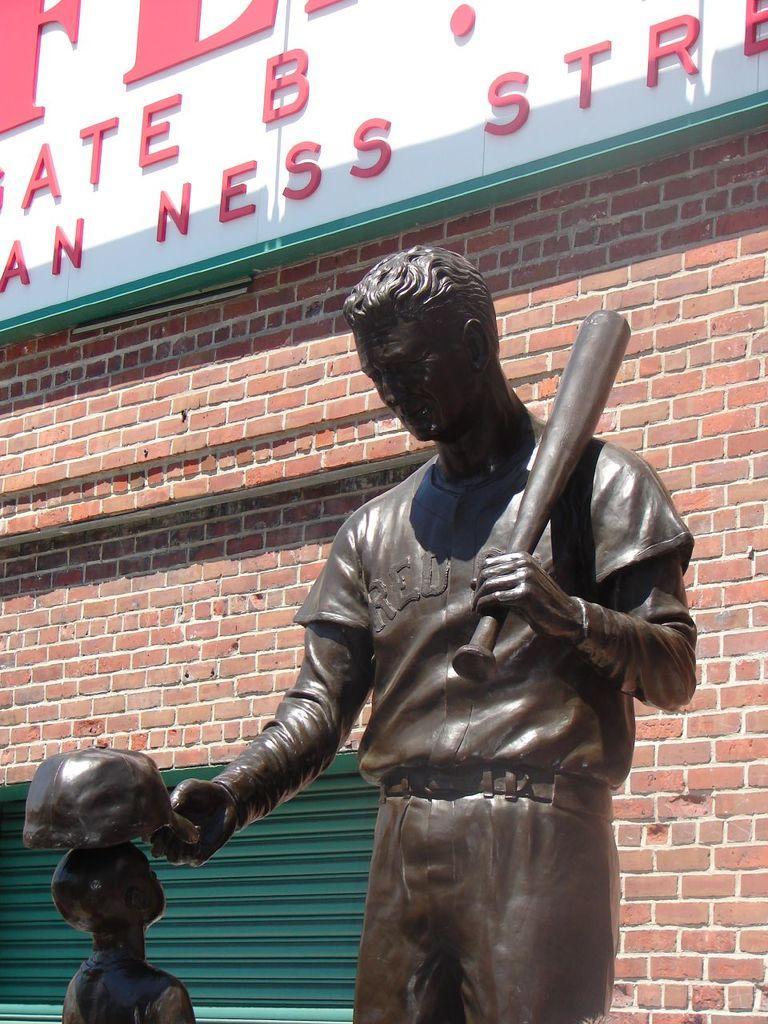Describe this image in one or two sentences. In this picture I can observe a statue of a human holding a baseball bat. The statue is in brown color. I can observe a white color board on which there is some text which is in red color. In the background there is a wall and a green color shutter. 